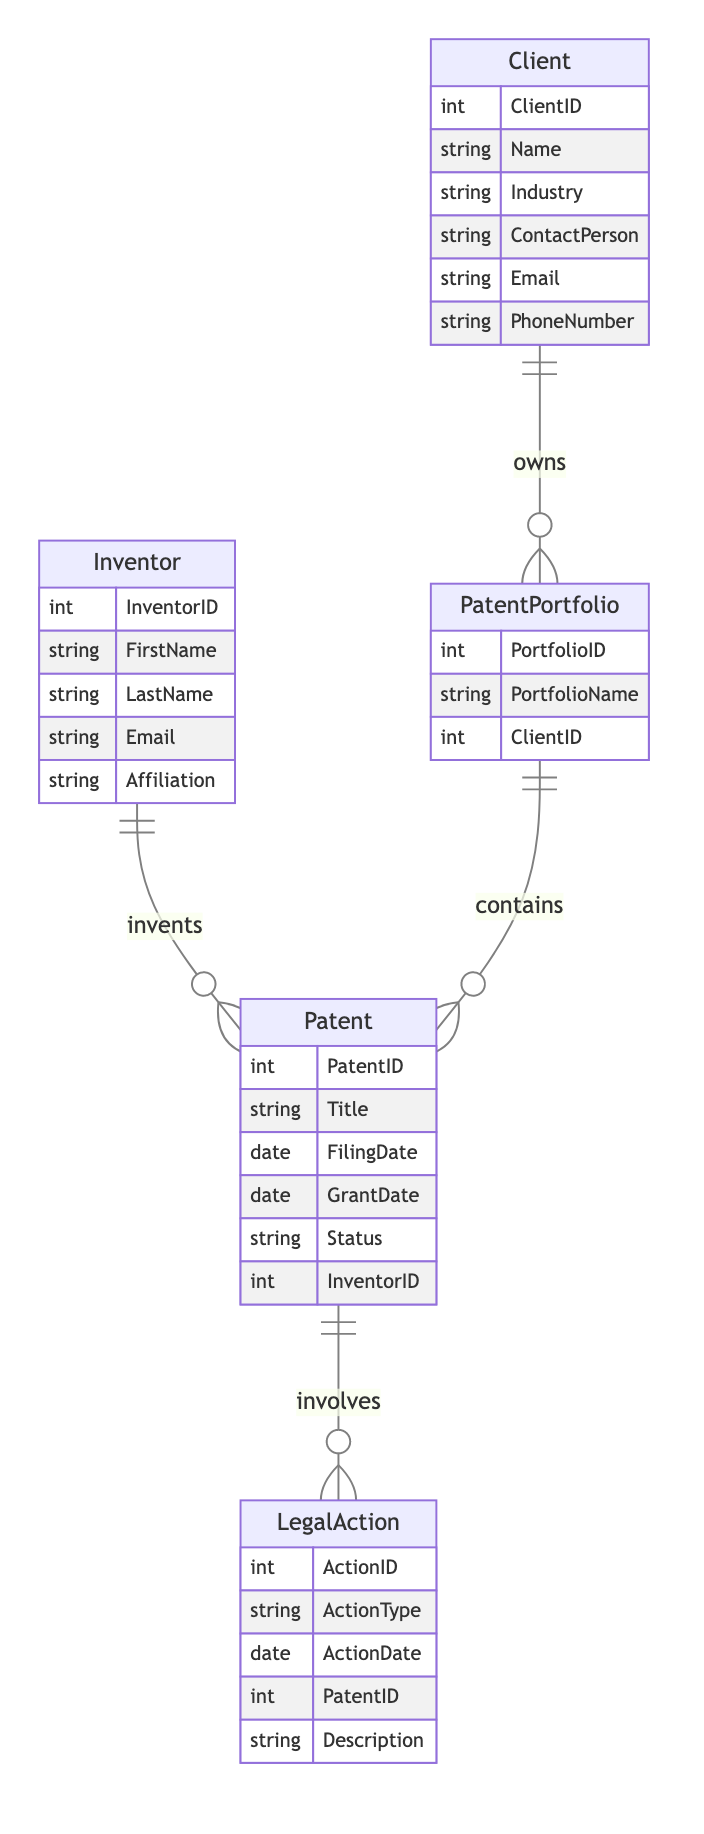What is the maximum number of inventors associated with a single patent? The diagram shows a many-to-many relationship between Inventor and Patent, indicating that a single patent can have multiple inventors. However, the specific number of inventors that can be associated with a patent is not stated within the diagram. Thus, the answer is not defined in the information provided.
Answer: Undefined How many attributes does the Client entity have? The Client entity is shown with six attributes: ClientID, Name, Industry, ContactPerson, Email, and PhoneNumber. Counting these gives us six total attributes.
Answer: Six What type of relationship exists between Patent and LegalAction? The diagram indicates a one-to-many relationship between Patent and LegalAction, meaning each patent can have multiple legal actions associated with it, but each legal action is linked to one specific patent.
Answer: One-to-many How many entities are there in the diagram? The diagram includes five entities: Patent, Inventor, Client, PatentPortfolio, and LegalAction. By counting these entities, we find there are five total.
Answer: Five Which entity contains the PortfolioID attribute? The PatentPortfolio entity is specified to contain the PortfolioID attribute, linking it to the broader management of patent portfolios.
Answer: PatentPortfolio What is the relationship type between Client and PatentPortfolio? Based on the diagram, there is a one-to-many relationship between Client and PatentPortfolio, indicating that a client can own multiple patent portfolios.
Answer: One-to-many How many patents can be included in a single patent portfolio? The relationship defined between PatentPortfolio and Patent is one-to-many, suggesting that one patent portfolio can include multiple patents. However, the exact number of patents that can be included is not specified in the diagram.
Answer: Undefined What is the primary purpose of the LegalAction entity in this diagram? The LegalAction entity is involved in tracking actions related to patents, which includes details such as ActionType and ActionDate, indicating its purpose is to manage legal actions associated with patents.
Answer: Manage legal actions Who can have multiple patents according to the diagram? The Inventor entity can have multiple patents as indicated by the many-to-many relationship between Inventor and Patent, meaning an inventor can invent several patents.
Answer: Inventor 